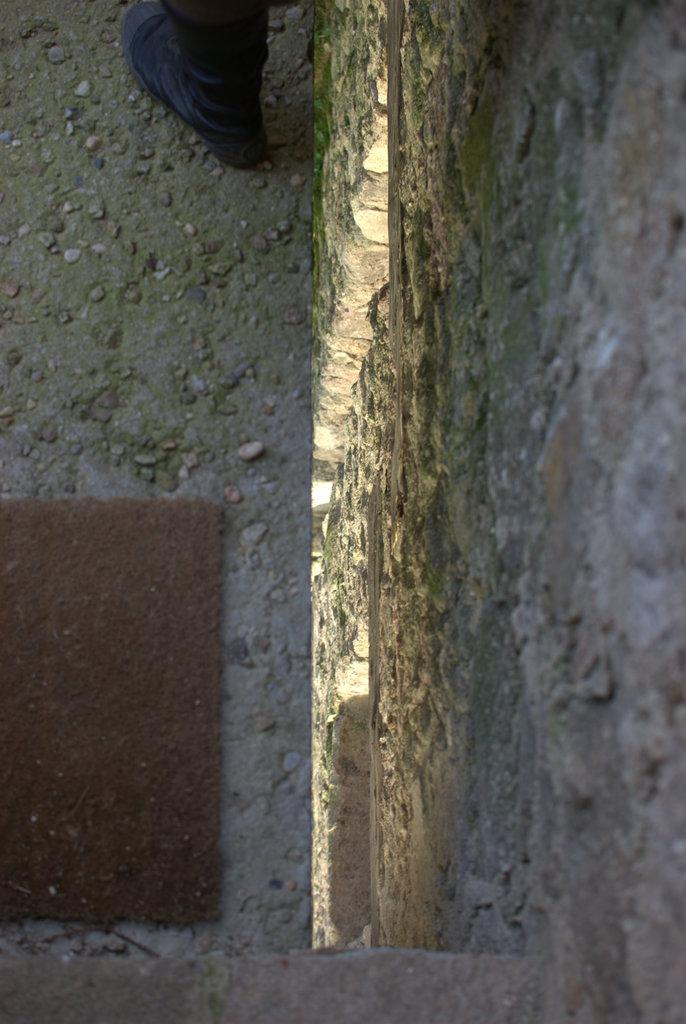What is on the floor in the image? There is a mat on the floor in the image. What can be seen in the background of the image? There is a wall visible in the image. Can you describe any part of a person in the image? A person's leg is present in the image. Are there any lizards visible in the image? There are no lizards present in the image. Is the person in the image stuck in quicksand? There is no indication of quicksand or any person being stuck in the image. 